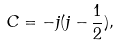Convert formula to latex. <formula><loc_0><loc_0><loc_500><loc_500>C = - j ( j - \frac { 1 } { 2 } ) ,</formula> 